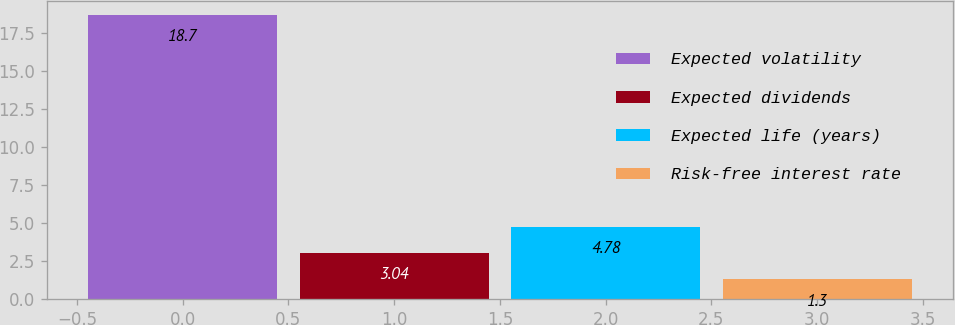Convert chart. <chart><loc_0><loc_0><loc_500><loc_500><bar_chart><fcel>Expected volatility<fcel>Expected dividends<fcel>Expected life (years)<fcel>Risk-free interest rate<nl><fcel>18.7<fcel>3.04<fcel>4.78<fcel>1.3<nl></chart> 